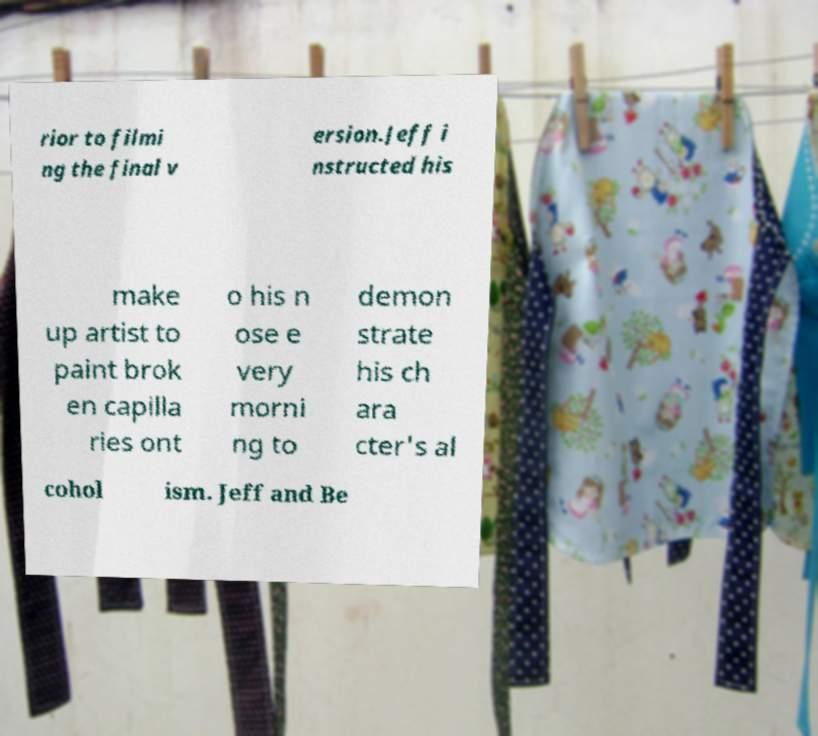Please read and relay the text visible in this image. What does it say? rior to filmi ng the final v ersion.Jeff i nstructed his make up artist to paint brok en capilla ries ont o his n ose e very morni ng to demon strate his ch ara cter's al cohol ism. Jeff and Be 